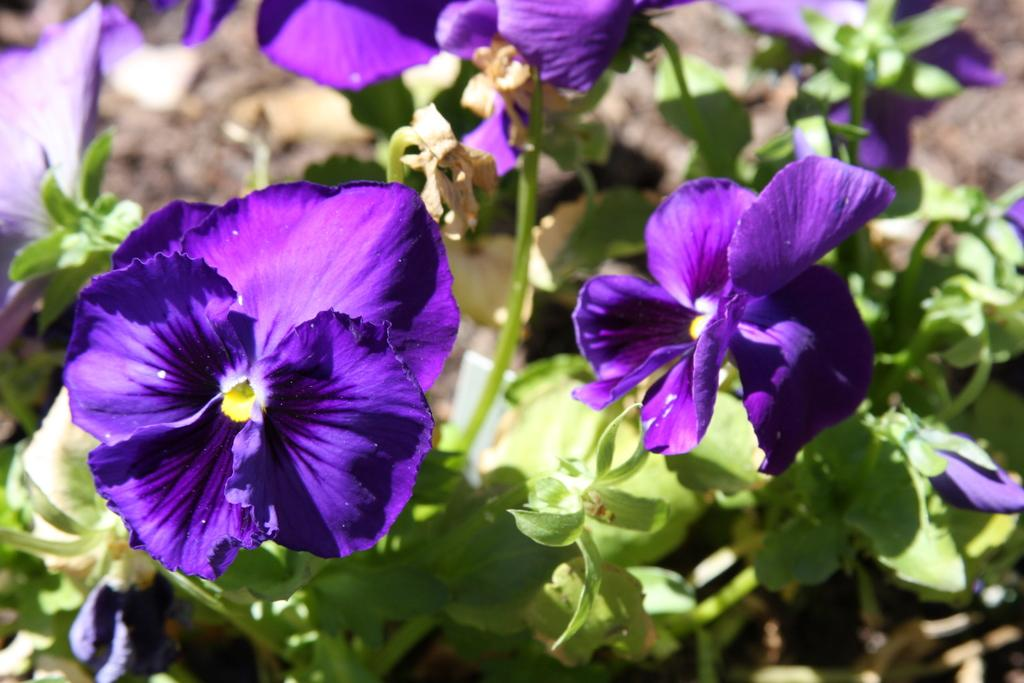What type of living organisms can be seen in the image? Plants can be seen in the image. Do the plants have any specific features? Yes, the plants have flowers. Where are the plants and flowers located in the image? The plants and flowers are on the ground. Can you tell me how many cows are grazing among the plants in the image? There are no cows present in the image; it only features plants and flowers. What type of tail can be seen on the plants in the image? There are no tails present on the plants in the image, as plants do not have tails. 